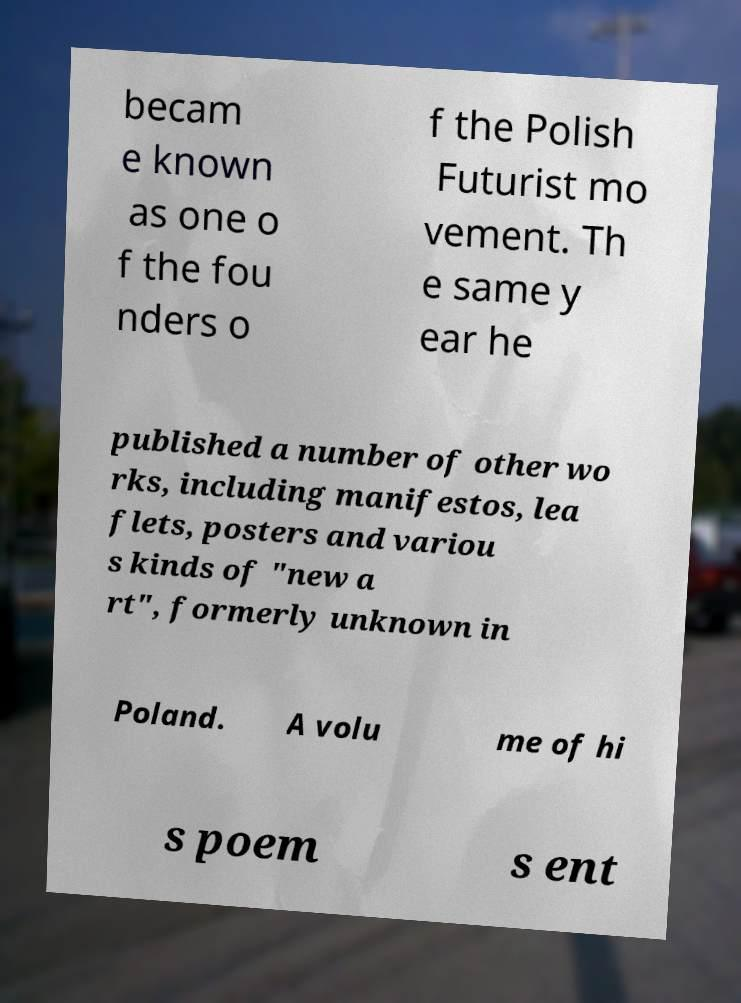Please identify and transcribe the text found in this image. becam e known as one o f the fou nders o f the Polish Futurist mo vement. Th e same y ear he published a number of other wo rks, including manifestos, lea flets, posters and variou s kinds of "new a rt", formerly unknown in Poland. A volu me of hi s poem s ent 